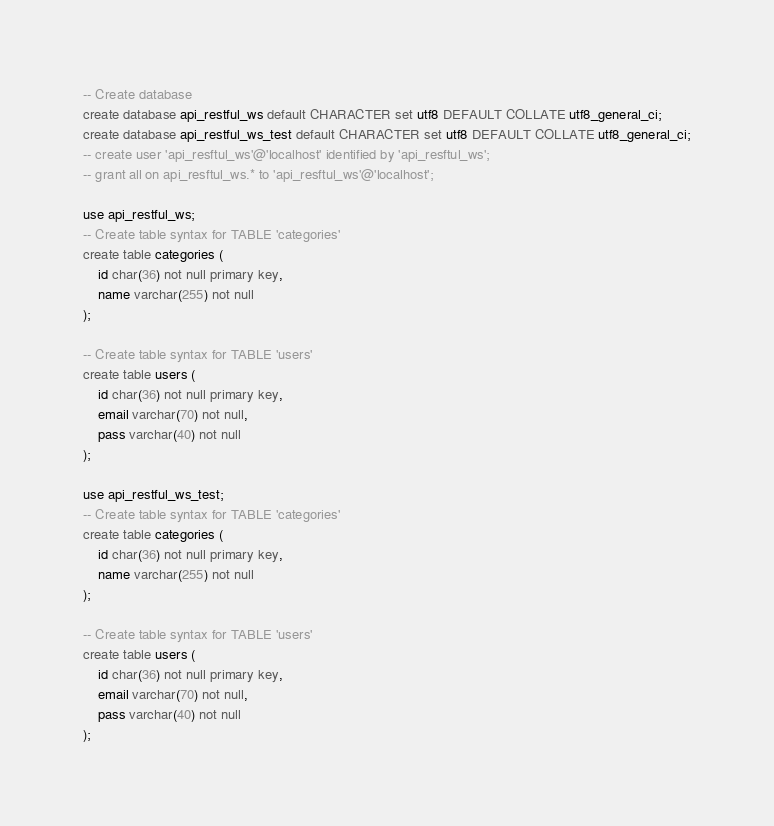Convert code to text. <code><loc_0><loc_0><loc_500><loc_500><_SQL_>-- Create database
create database api_restful_ws default CHARACTER set utf8 DEFAULT COLLATE utf8_general_ci;
create database api_restful_ws_test default CHARACTER set utf8 DEFAULT COLLATE utf8_general_ci;
-- create user 'api_resftul_ws'@'localhost' identified by 'api_resftul_ws';
-- grant all on api_resftul_ws.* to 'api_resftul_ws'@'localhost';

use api_restful_ws;
-- Create table syntax for TABLE 'categories'
create table categories (
    id char(36) not null primary key,
    name varchar(255) not null
);

-- Create table syntax for TABLE 'users'
create table users (
    id char(36) not null primary key,
    email varchar(70) not null,
    pass varchar(40) not null
);

use api_restful_ws_test;
-- Create table syntax for TABLE 'categories'
create table categories (
    id char(36) not null primary key,
    name varchar(255) not null
);

-- Create table syntax for TABLE 'users'
create table users (
    id char(36) not null primary key,
    email varchar(70) not null,
    pass varchar(40) not null
);
</code> 